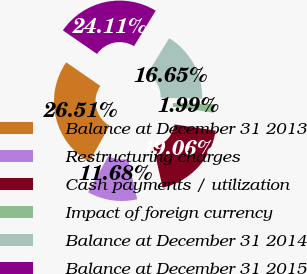Convert chart to OTSL. <chart><loc_0><loc_0><loc_500><loc_500><pie_chart><fcel>Balance at December 31 2013<fcel>Restructuring charges<fcel>Cash payments / utilization<fcel>Impact of foreign currency<fcel>Balance at December 31 2014<fcel>Balance at December 31 2015<nl><fcel>26.51%<fcel>11.68%<fcel>19.06%<fcel>1.99%<fcel>16.65%<fcel>24.11%<nl></chart> 